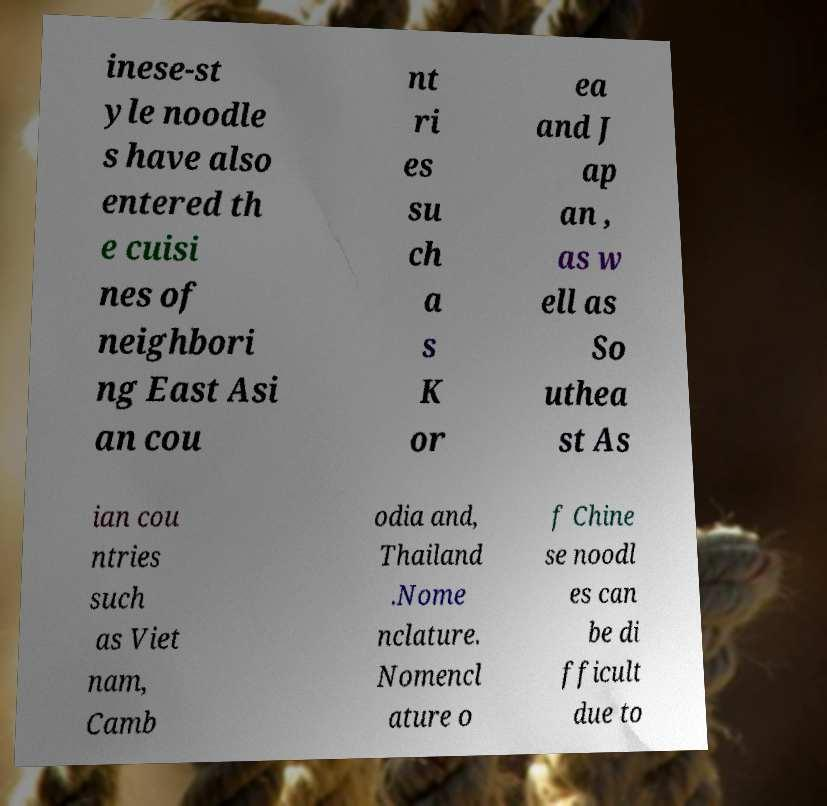Please identify and transcribe the text found in this image. inese-st yle noodle s have also entered th e cuisi nes of neighbori ng East Asi an cou nt ri es su ch a s K or ea and J ap an , as w ell as So uthea st As ian cou ntries such as Viet nam, Camb odia and, Thailand .Nome nclature. Nomencl ature o f Chine se noodl es can be di fficult due to 